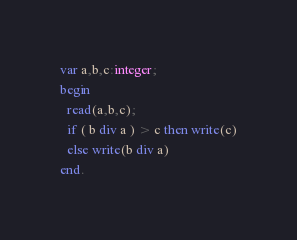<code> <loc_0><loc_0><loc_500><loc_500><_Pascal_>var a,b,c:integer;
begin
  read(a,b,c);
  if ( b div a ) > c then write(c)
  else write(b div a)
end.
</code> 